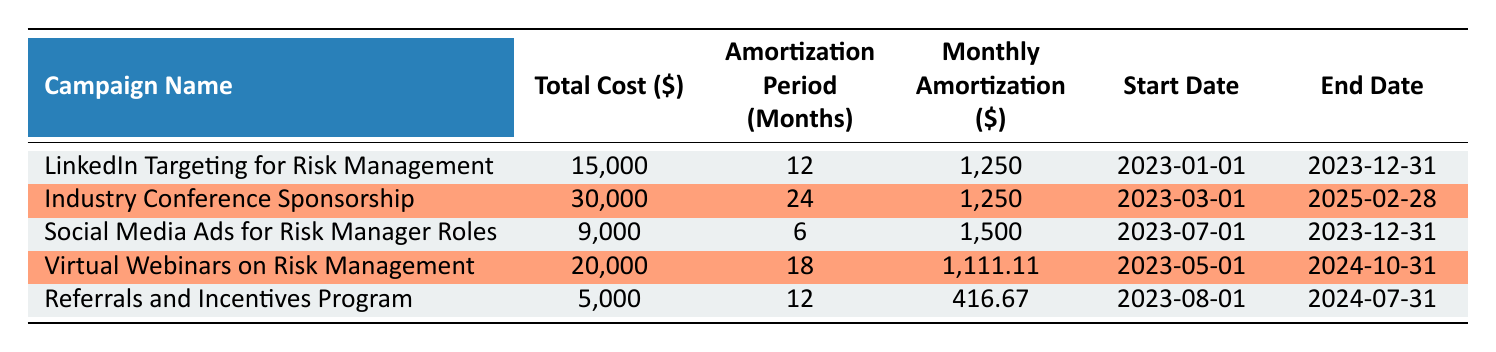What is the total cost of the "Industry Conference Sponsorship" campaign? The total cost of the "Industry Conference Sponsorship" campaign is directly listed in the table under the "Total Cost" column. The value is 30,000.
Answer: 30,000 What is the amortization period for "Social Media Ads for Risk Manager Roles"? The amortization period is explicitly provided in the table under the "Amortization Period (Months)" column. For "Social Media Ads for Risk Manager Roles," the period is 6 months.
Answer: 6 months Which campaign has the highest monthly amortization amount? To determine the highest monthly amortization amount, we compare the "Monthly Amortization" values of all campaigns listed in the table. The "Social Media Ads for Risk Manager Roles" has the highest amount at 1,500.
Answer: Social Media Ads for Risk Manager Roles Is the total cost of "Referrals and Incentives Program" greater than 10,000? We check the total cost of "Referrals and Incentives Program," which is listed as 5,000 in the table. Since 5,000 is not greater than 10,000, the answer is false.
Answer: No What is the average monthly amortization across all campaigns? First, we find the monthly amortization for each campaign: 1,250, 1,250, 1,500, 1,111.11, and 416.67. We sum these values (1,250 + 1,250 + 1,500 + 1,111.11 + 416.67 = 5,528.78) and divide by the number of campaigns (5). The average monthly amortization is 5,528.78 / 5 = 1,105.76.
Answer: 1,105.76 Which campaign has the longest amortization period and what is that period? We review the "Amortization Period (Months)" of each campaign and identify the maximum value. The "Industry Conference Sponsorship" has the longest amortization period of 24 months.
Answer: Industry Conference Sponsorship, 24 months What is the total cost of campaigns that end in 2023? We identify the campaigns with end dates in 2023: "LinkedIn Targeting for Risk Management" (15,000), "Social Media Ads for Risk Manager Roles" (9,000), and "Referrals and Incentives Program" (5,000). Summing these amounts (15,000 + 9,000 + 5,000) gives us 29,000 as the total cost.
Answer: 29,000 